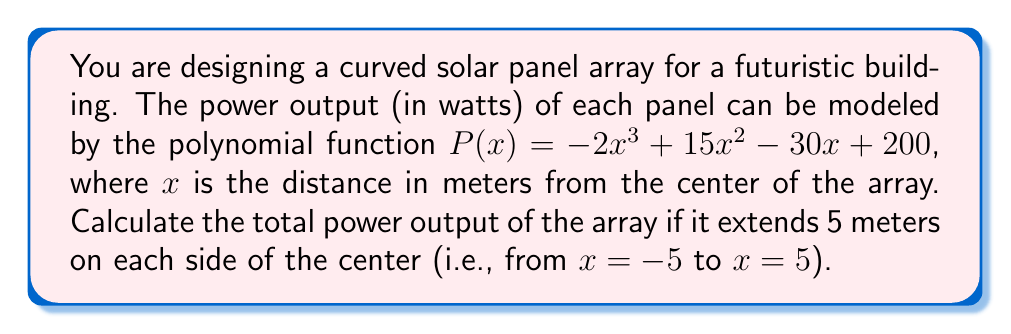Help me with this question. To solve this problem, we need to integrate the polynomial function over the given range. Here's the step-by-step solution:

1) The total power output is given by the definite integral of $P(x)$ from $-5$ to $5$:

   $$\int_{-5}^{5} P(x) dx = \int_{-5}^{5} (-2x^3 + 15x^2 - 30x + 200) dx$$

2) Integrate each term:
   
   $$\left[-\frac{1}{2}x^4 + 5x^3 - 15x^2 + 200x\right]_{-5}^{5}$$

3) Evaluate at the upper and lower limits:

   $$\left(-\frac{1}{2}(5)^4 + 5(5)^3 - 15(5)^2 + 200(5)\right) - \left(-\frac{1}{2}(-5)^4 + 5(-5)^3 - 15(-5)^2 + 200(-5)\right)$$

4) Simplify:

   $$(-312.5 + 625 - 375 + 1000) - (-312.5 - 625 - 375 - 1000)$$
   
   $$= 937.5 - (-2312.5)$$
   
   $$= 937.5 + 2312.5$$
   
   $$= 3250$$

Therefore, the total power output of the array is 3250 watts.
Answer: 3250 watts 